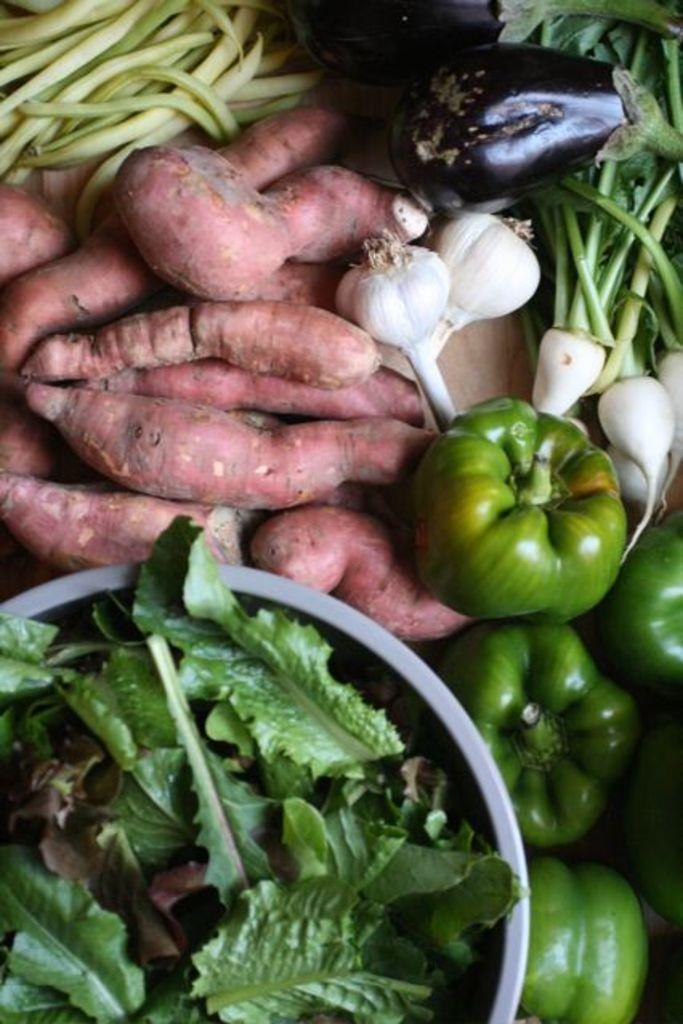What type of vegetables are in the bowl in the image? There are leafy vegetables in a bowl in the image. What other vegetables can be seen in the image? There are capsicums, beans, and a brinjal in the image. Are there any other ingredients visible in the image? Yes, there is garlic in the image. What type of surface is present in the image? The wooden surface is present in the image. What invention is being demonstrated by the wren in the image? There is no wren or invention present in the image; it features various vegetables and a wooden surface. 